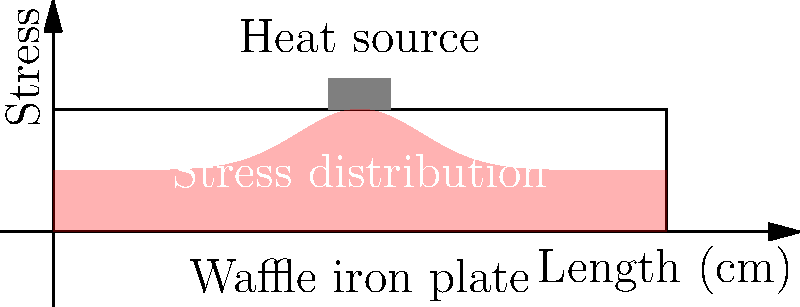A Belgian waffle iron's heating plate is 10 cm long and subjected to a concentrated heat source at its center. Assuming the plate is made of cast iron and fixed at both ends, how would you describe the stress distribution along the length of the plate? To understand the stress distribution in the waffle iron's heating plate, let's follow these steps:

1. Material properties: Cast iron has a relatively low thermal conductivity compared to other metals, which affects heat distribution.

2. Boundary conditions: The plate is fixed at both ends, which restricts thermal expansion and induces thermal stresses.

3. Heat source: The concentrated heat source at the center creates a temperature gradient along the plate's length.

4. Thermal expansion: As the plate heats up, it tries to expand, but the fixed ends prevent this, causing compressive stresses.

5. Stress distribution:
   a. Maximum stress occurs at the center where the heat source is located due to the highest temperature and restricted expansion.
   b. Stress decreases towards the ends of the plate as the temperature gradient becomes less severe.
   c. The stress distribution follows a bell-shaped curve, similar to a normal distribution.

6. Mathematical representation: The stress distribution can be approximated by the equation:

   $$\sigma(x) = \sigma_{\max} \cdot e^{-k(x-L/2)^2}$$

   Where:
   $\sigma(x)$ is the stress at position $x$
   $\sigma_{\max}$ is the maximum stress at the center
   $k$ is a constant depending on material properties and heating conditions
   $L$ is the length of the plate (10 cm)

7. Factors affecting stress magnitude:
   a. Temperature difference between the center and the ends
   b. Thermal expansion coefficient of cast iron
   c. Young's modulus of the material
   d. Plate thickness

In practice, this stress distribution may lead to potential warping or cracking of the waffle iron plate over time, especially at the center where stress is highest.
Answer: Bell-shaped distribution with maximum stress at the center, decreasing towards the fixed ends. 